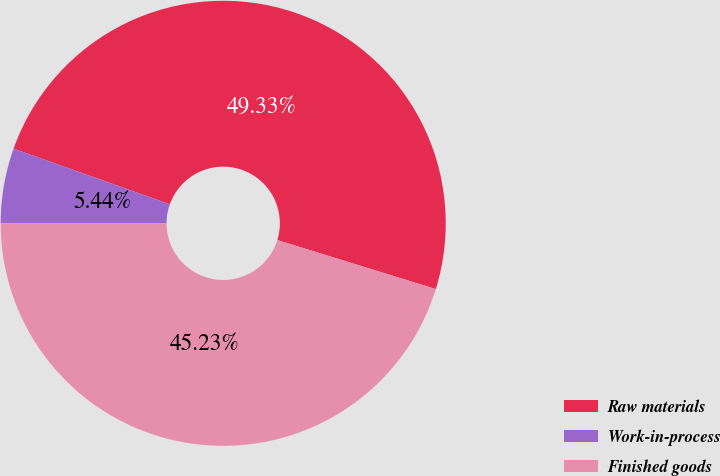Convert chart to OTSL. <chart><loc_0><loc_0><loc_500><loc_500><pie_chart><fcel>Raw materials<fcel>Work-in-process<fcel>Finished goods<nl><fcel>49.33%<fcel>5.44%<fcel>45.23%<nl></chart> 